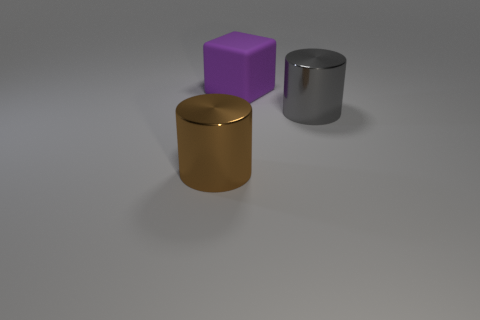Add 2 big purple blocks. How many objects exist? 5 Subtract all cubes. How many objects are left? 2 Subtract all shiny cylinders. Subtract all gray metallic cylinders. How many objects are left? 0 Add 1 big metallic objects. How many big metallic objects are left? 3 Add 3 tiny brown cylinders. How many tiny brown cylinders exist? 3 Subtract 0 blue balls. How many objects are left? 3 